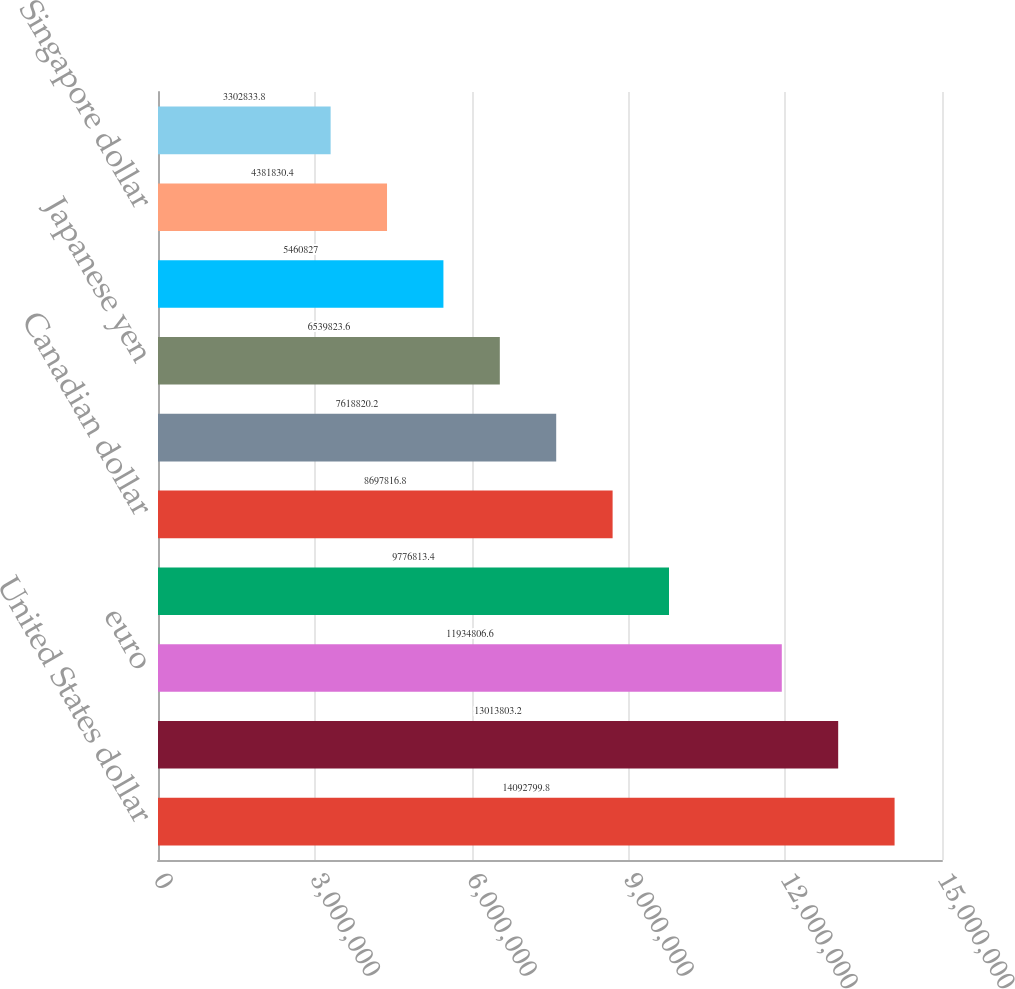Convert chart to OTSL. <chart><loc_0><loc_0><loc_500><loc_500><bar_chart><fcel>United States dollar<fcel>British pound sterling<fcel>euro<fcel>Australian dollar<fcel>Canadian dollar<fcel>Indian rupee<fcel>Japanese yen<fcel>Chinese yuan<fcel>Singapore dollar<fcel>Hong Kong dollar<nl><fcel>1.40928e+07<fcel>1.30138e+07<fcel>1.19348e+07<fcel>9.77681e+06<fcel>8.69782e+06<fcel>7.61882e+06<fcel>6.53982e+06<fcel>5.46083e+06<fcel>4.38183e+06<fcel>3.30283e+06<nl></chart> 